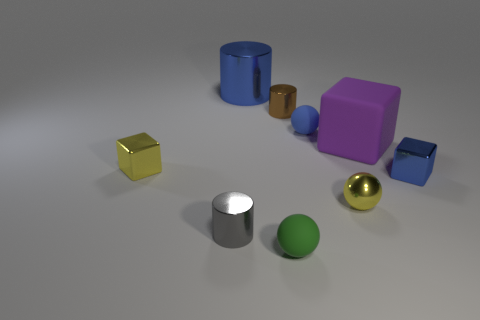Add 1 small green cubes. How many objects exist? 10 Add 3 small green things. How many small green things are left? 4 Add 7 tiny balls. How many tiny balls exist? 10 Subtract 1 blue cubes. How many objects are left? 8 Subtract all cylinders. How many objects are left? 6 Subtract all small things. Subtract all purple matte blocks. How many objects are left? 1 